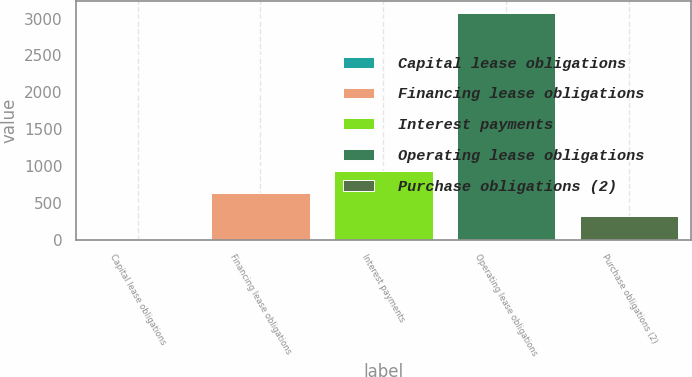<chart> <loc_0><loc_0><loc_500><loc_500><bar_chart><fcel>Capital lease obligations<fcel>Financing lease obligations<fcel>Interest payments<fcel>Operating lease obligations<fcel>Purchase obligations (2)<nl><fcel>14<fcel>627.2<fcel>933.8<fcel>3080<fcel>320.6<nl></chart> 